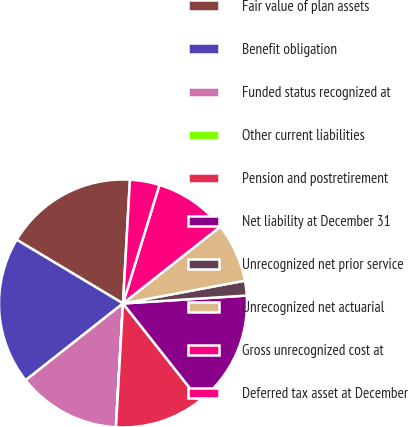Convert chart. <chart><loc_0><loc_0><loc_500><loc_500><pie_chart><fcel>Fair value of plan assets<fcel>Benefit obligation<fcel>Funded status recognized at<fcel>Other current liabilities<fcel>Pension and postretirement<fcel>Net liability at December 31<fcel>Unrecognized net prior service<fcel>Unrecognized net actuarial<fcel>Gross unrecognized cost at<fcel>Deferred tax asset at December<nl><fcel>17.3%<fcel>19.22%<fcel>13.46%<fcel>0.01%<fcel>11.54%<fcel>15.38%<fcel>1.93%<fcel>7.69%<fcel>9.62%<fcel>3.85%<nl></chart> 